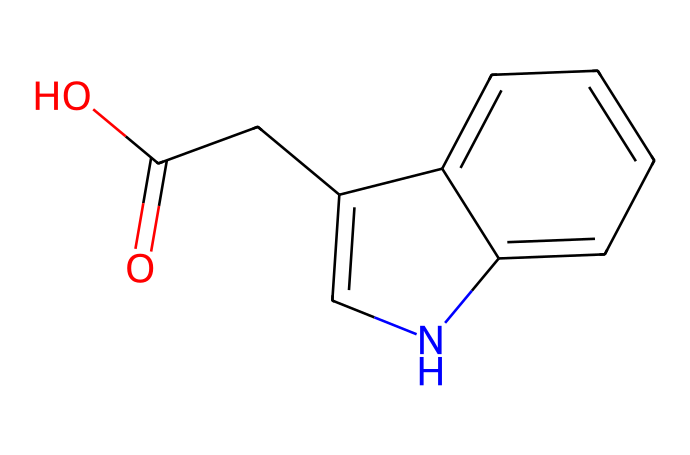What is the molecular formula of this auxin? To determine the molecular formula, we count the number of each type of atom in the chemical structure. The structure contains 12 carbons (C), 11 hydrogens (H), 1 nitrogen (N), and 2 oxygens (O). Therefore, the molecular formula is C12H11N2O2.
Answer: C12H11N2O2 How many rings are present in the structure? By analyzing the structure, we can identify that there are two fused rings, which can be seen from the cyclic nature of the molecular structure. Therefore, the answer is 2.
Answer: 2 What functional groups are present in this auxin? The chemical structure includes a carboxylic acid group (−COOH) indicated by the -C(=O)O and an aromatic amine group due to the presence of the nitrogen atom within the ring structure. Therefore, the functional groups identified are -COOH and aryl amine.
Answer: -COOH, aryl amine What is the significance of the nitrogen atom in this auxin? The nitrogen atom in the structure suggests that this auxin may have similar properties to other nitrogen-containing plant hormones, influencing physiological processes such as growth and development. Its presence is crucial for the hormone's function.
Answer: crucial for function How many stereoisomers can this chemical have? This chemical does not have any chiral centers, as there are no carbon atoms bonded to four different groups; thus, it has no stereoisomers. The answer is 1, representing the single isomer.
Answer: 1 Is this auxin likely to promote cell elongation? Auxins are well-known for promoting cell elongation in plants. Since this chemical structure fits the characteristics of auxins, it is likely to promote this physiological response based on known functions of auxins.
Answer: likely 